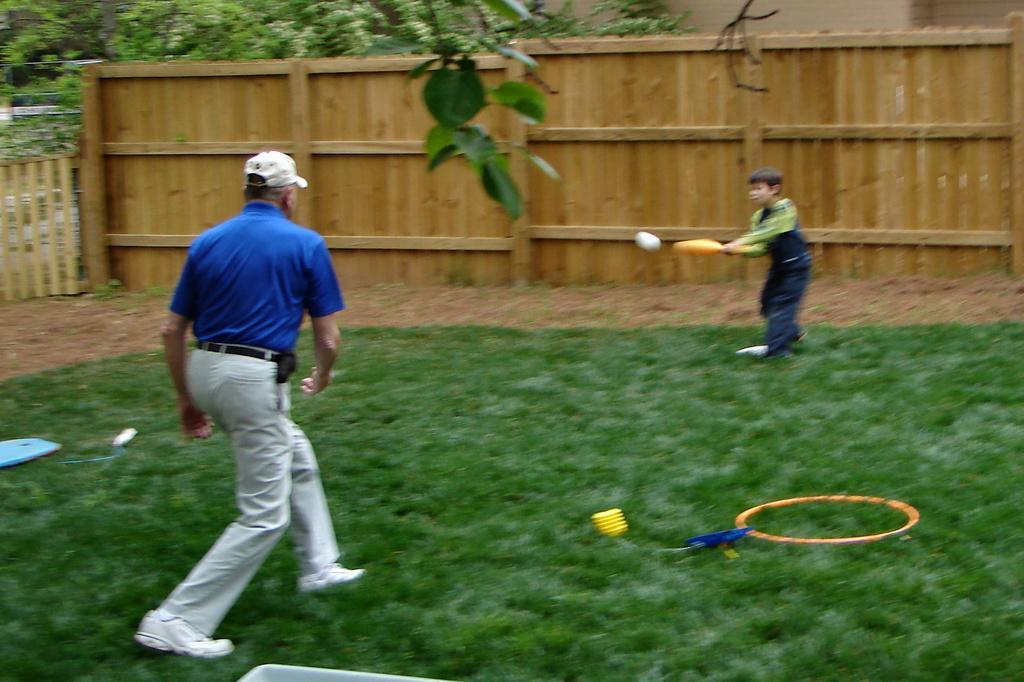Describe this image in one or two sentences. In this image I can see two persons standing, the person in front wearing blue shirt, white pant and I can see a bat and a ball, in front I can see the other person wearing black color dress and I can see grass and trees in green color, and I can see a wooden wall in brown color. 